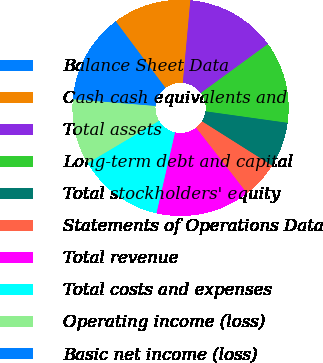Convert chart. <chart><loc_0><loc_0><loc_500><loc_500><pie_chart><fcel>Balance Sheet Data<fcel>Cash cash equivalents and<fcel>Total assets<fcel>Long-term debt and capital<fcel>Total stockholders' equity<fcel>Statements of Operations Data<fcel>Total revenue<fcel>Total costs and expenses<fcel>Operating income (loss)<fcel>Basic net income (loss)<nl><fcel>4.91%<fcel>11.66%<fcel>13.5%<fcel>12.27%<fcel>6.75%<fcel>5.52%<fcel>14.11%<fcel>12.88%<fcel>9.82%<fcel>8.59%<nl></chart> 